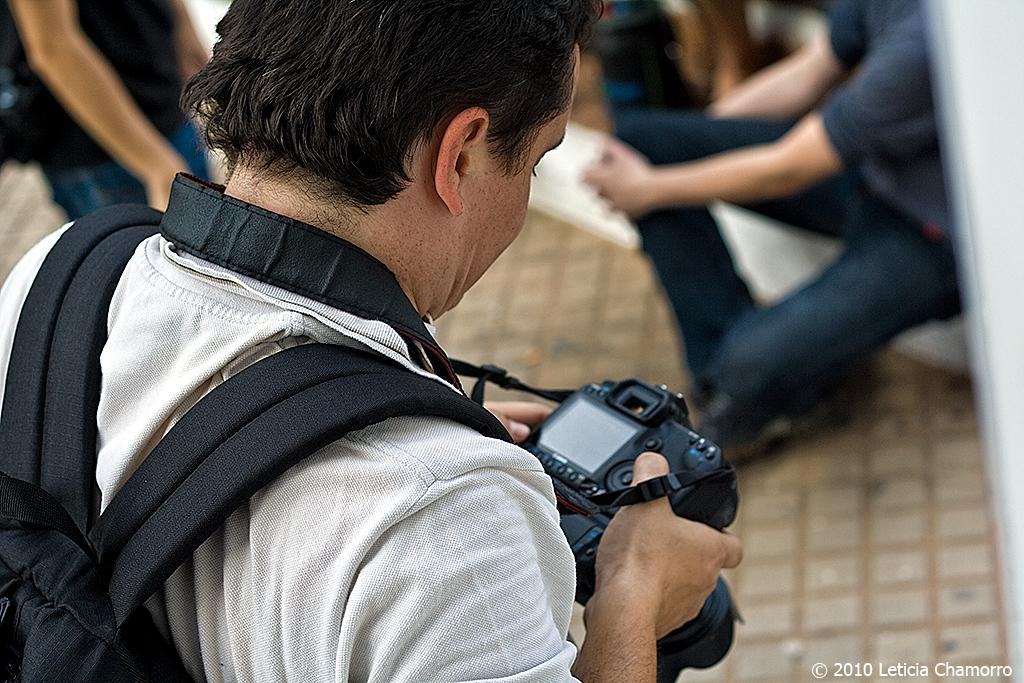What is the person in the image doing? The person is standing and holding a camera in the image. Can you describe the people in the background of the image? Some of the people in the background are standing, while others are sitting on the floor. What might the person holding the camera be planning to do? The person holding the camera might be planning to take a picture or record a video. What invention is being taught in the class visible in the image? There is no class visible in the image, so it is not possible to determine what invention might be taught. 